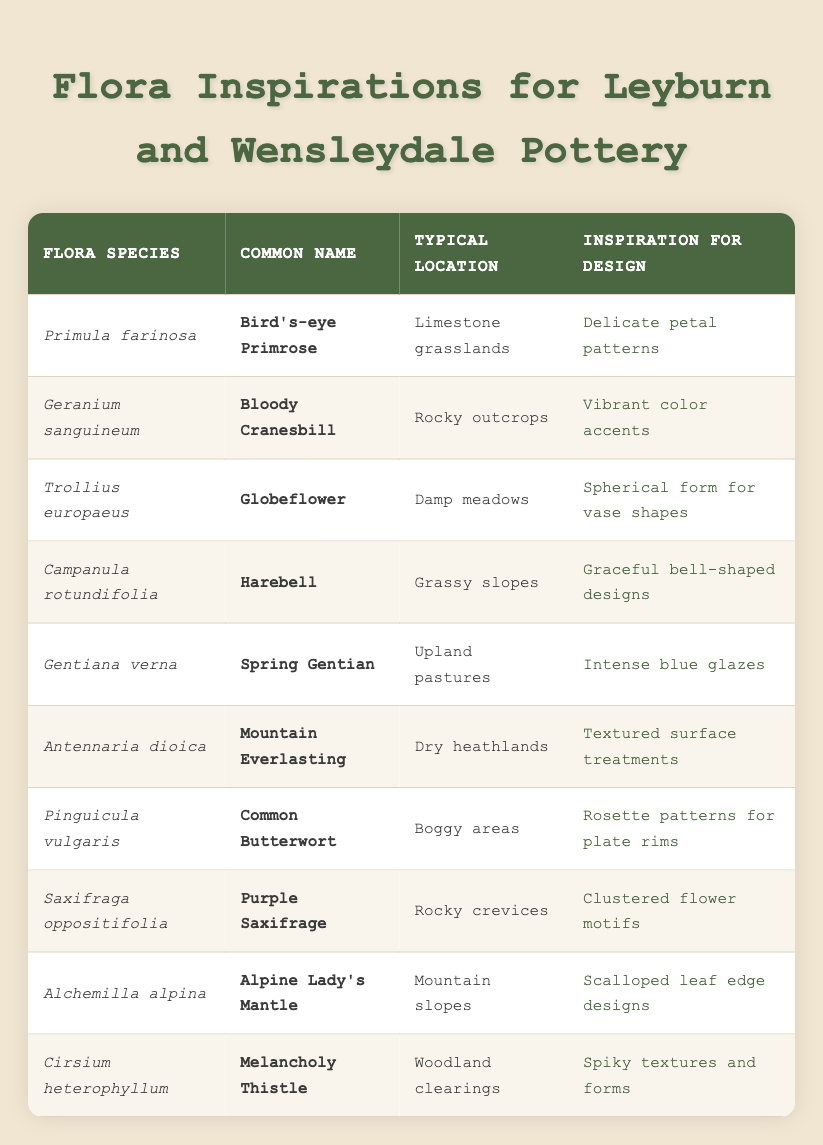What is the common name of Primula farinosa? Looking at the table under the "Common Name" column and finding the row with "Primula farinosa", we see the corresponding common name is "Bird's-eye Primrose".
Answer: Bird's-eye Primrose Which flora species is known to grow in boggy areas? In the "Typical Location" column, we can identify rows that mention "Boggy areas". The flora species listed for this location is "Pinguicula vulgaris".
Answer: Pinguicula vulgaris What design inspiration is derived from Saxifraga oppositifolia? By checking the row for "Saxifraga oppositifolia", we see that the design inspiration listed is "Clustered flower motifs".
Answer: Clustered flower motifs How many flora species are associated with the term "spikes or spikes" in their design inspiration? Reviewing the "Inspiration for Design" column, we find "Cirsium heterophyllum" features "Spiky textures and forms". Therefore, only one species corresponds to this description.
Answer: 1 Does the Spring Gentian grow in limestone grasslands? By cross-examining the "Typical Location" of "Gentiana verna" (Spring Gentian), we find that it grows in "Upland pastures", not limestone grasslands. Therefore, the answer is false.
Answer: No Which design inspirations are linked to flora species found in dry heathlands? Looking at the "Typical Location" column, "Antennaria dioica" is associated with "Dry heathlands". Referring to the corresponding design inspiration, it is "Textured surface treatments".
Answer: Textured surface treatments List the common names of flora species that inspire design through colors (mentioning any color). Scanning the "Inspiration for Design" column, we find "Bloody Cranesbill" for "Vibrant color accents" and "Gentiana verna" for "Intense blue glazes". This includes two species. The final answer will highlight these species as their inspiration is color-related.
Answer: Bloody Cranesbill, Spring Gentian Which flora species have design inspirations related to shapes (spherical or bell)? Observing the inspirations, "Trollius europaeus" emphasizes a "Spherical form for vase shapes" and "Campanula rotundifolia" focuses on "Graceful bell-shaped designs". Thus, both species provide design inspirations related to shapes.
Answer: Trollius europaeus, Campanula rotundifolia Is there a flora species that grows specifically on rocky outcrops and inspires vibrant colors? Yes, "Geranium sanguineum" is noted for its growth on "Rocky outcrops" and its design inspiration is "Vibrant color accents". Thus, the statement is true.
Answer: Yes 